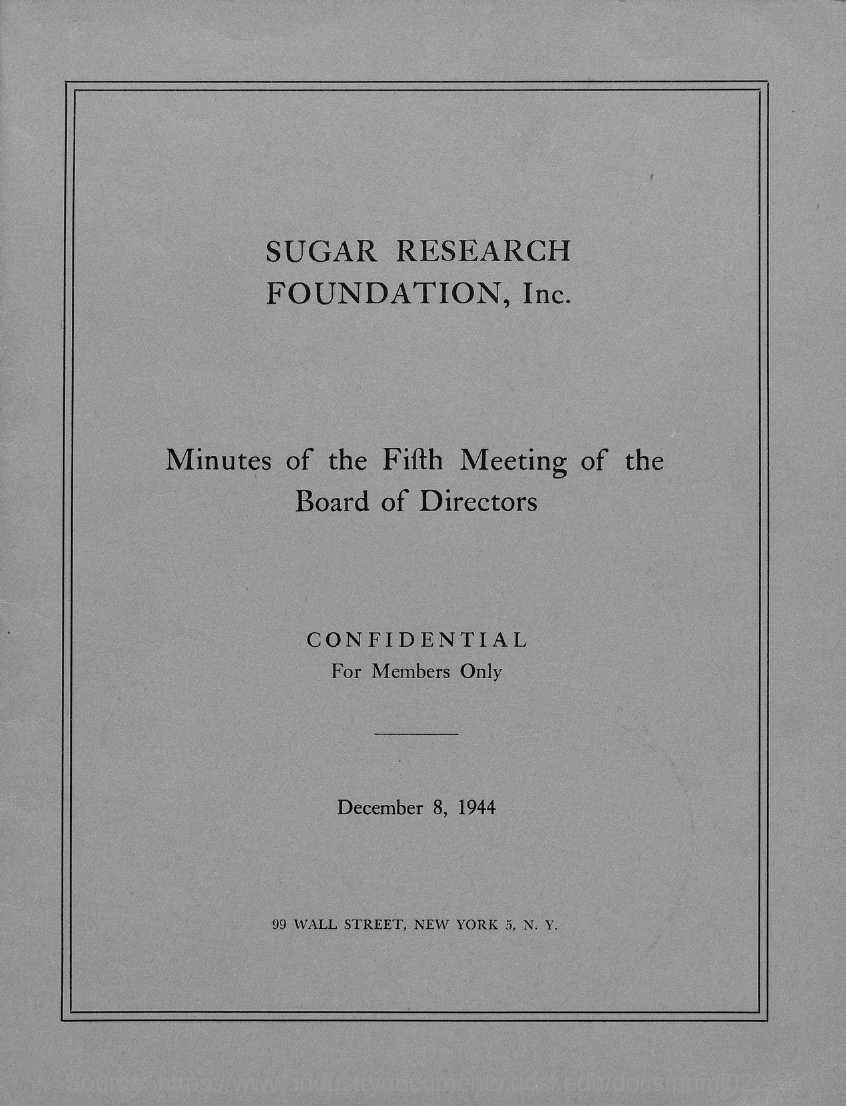What research foundation is this?
Provide a succinct answer. Sugar research foundation,inc. What is the date mentioned in the document?
Provide a short and direct response. DECEMBER 8, 1944. 